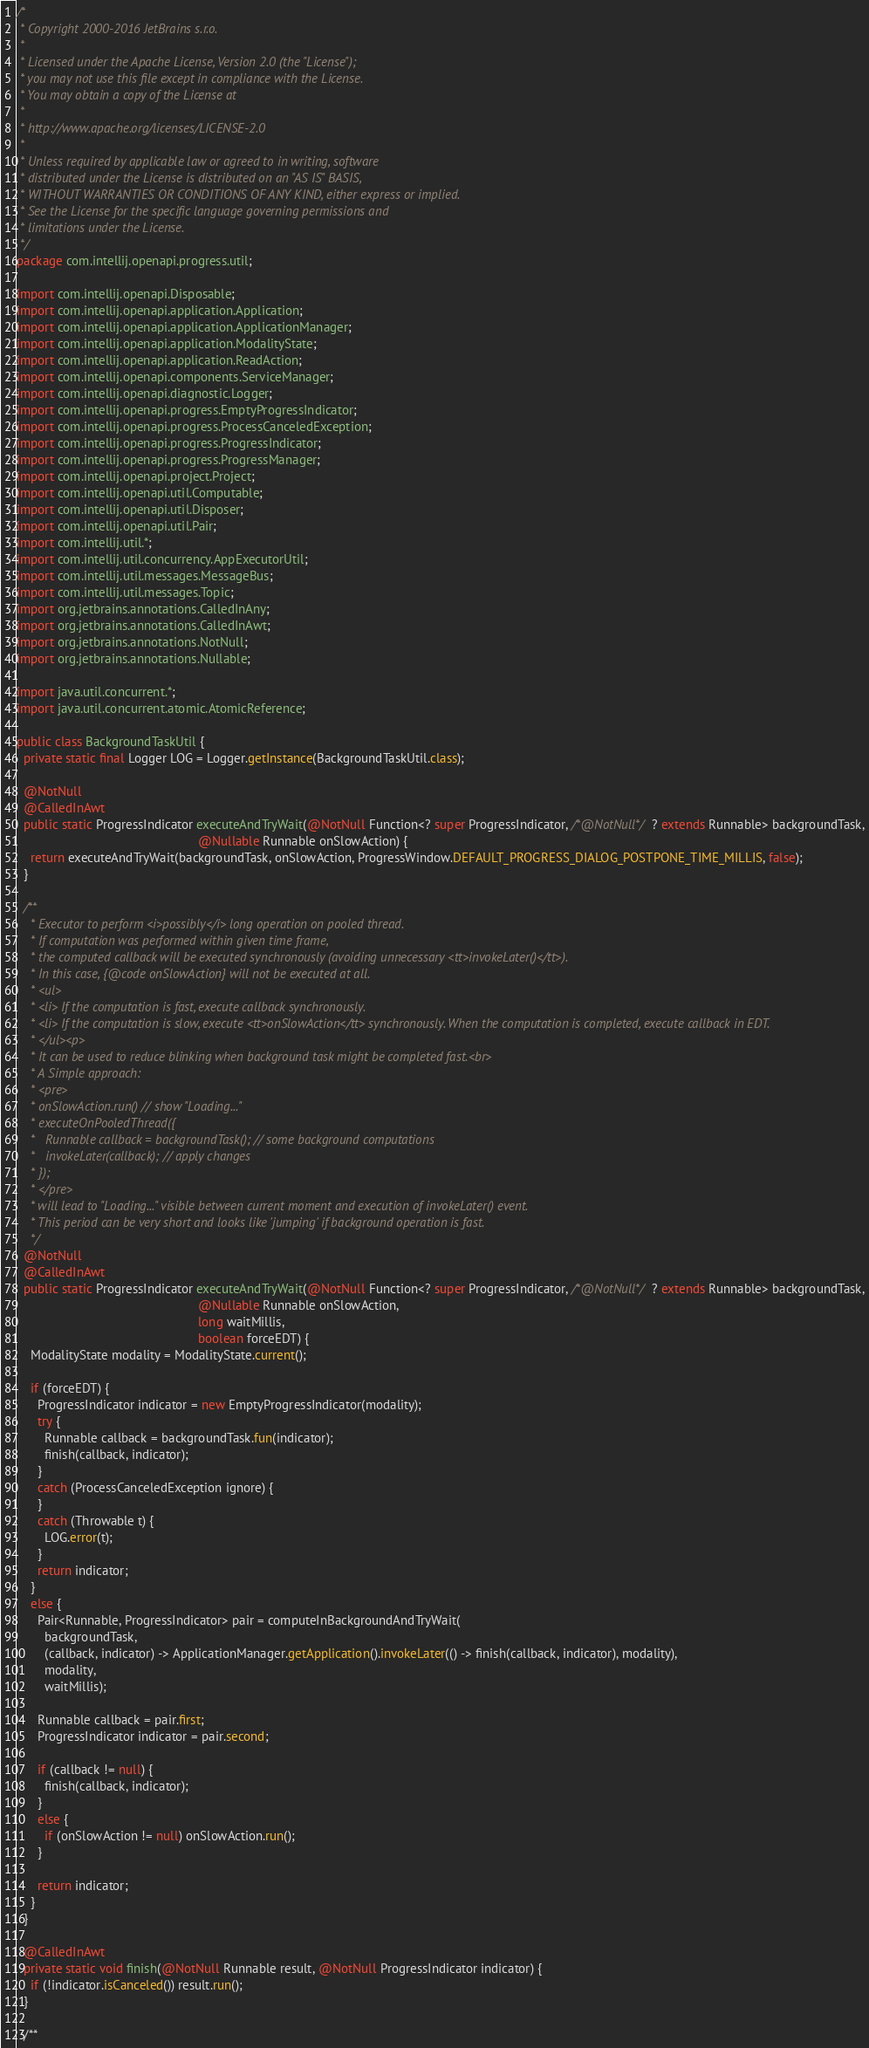Convert code to text. <code><loc_0><loc_0><loc_500><loc_500><_Java_>/*
 * Copyright 2000-2016 JetBrains s.r.o.
 *
 * Licensed under the Apache License, Version 2.0 (the "License");
 * you may not use this file except in compliance with the License.
 * You may obtain a copy of the License at
 *
 * http://www.apache.org/licenses/LICENSE-2.0
 *
 * Unless required by applicable law or agreed to in writing, software
 * distributed under the License is distributed on an "AS IS" BASIS,
 * WITHOUT WARRANTIES OR CONDITIONS OF ANY KIND, either express or implied.
 * See the License for the specific language governing permissions and
 * limitations under the License.
 */
package com.intellij.openapi.progress.util;

import com.intellij.openapi.Disposable;
import com.intellij.openapi.application.Application;
import com.intellij.openapi.application.ApplicationManager;
import com.intellij.openapi.application.ModalityState;
import com.intellij.openapi.application.ReadAction;
import com.intellij.openapi.components.ServiceManager;
import com.intellij.openapi.diagnostic.Logger;
import com.intellij.openapi.progress.EmptyProgressIndicator;
import com.intellij.openapi.progress.ProcessCanceledException;
import com.intellij.openapi.progress.ProgressIndicator;
import com.intellij.openapi.progress.ProgressManager;
import com.intellij.openapi.project.Project;
import com.intellij.openapi.util.Computable;
import com.intellij.openapi.util.Disposer;
import com.intellij.openapi.util.Pair;
import com.intellij.util.*;
import com.intellij.util.concurrency.AppExecutorUtil;
import com.intellij.util.messages.MessageBus;
import com.intellij.util.messages.Topic;
import org.jetbrains.annotations.CalledInAny;
import org.jetbrains.annotations.CalledInAwt;
import org.jetbrains.annotations.NotNull;
import org.jetbrains.annotations.Nullable;

import java.util.concurrent.*;
import java.util.concurrent.atomic.AtomicReference;

public class BackgroundTaskUtil {
  private static final Logger LOG = Logger.getInstance(BackgroundTaskUtil.class);

  @NotNull
  @CalledInAwt
  public static ProgressIndicator executeAndTryWait(@NotNull Function<? super ProgressIndicator, /*@NotNull*/ ? extends Runnable> backgroundTask,
                                                    @Nullable Runnable onSlowAction) {
    return executeAndTryWait(backgroundTask, onSlowAction, ProgressWindow.DEFAULT_PROGRESS_DIALOG_POSTPONE_TIME_MILLIS, false);
  }

  /**
    * Executor to perform <i>possibly</i> long operation on pooled thread.
    * If computation was performed within given time frame,
    * the computed callback will be executed synchronously (avoiding unnecessary <tt>invokeLater()</tt>).
    * In this case, {@code onSlowAction} will not be executed at all.
    * <ul>
    * <li> If the computation is fast, execute callback synchronously.
    * <li> If the computation is slow, execute <tt>onSlowAction</tt> synchronously. When the computation is completed, execute callback in EDT.
    * </ul><p>
    * It can be used to reduce blinking when background task might be completed fast.<br>
    * A Simple approach:
    * <pre>
    * onSlowAction.run() // show "Loading..."
    * executeOnPooledThread({
    *   Runnable callback = backgroundTask(); // some background computations
    *   invokeLater(callback); // apply changes
    * });
    * </pre>
    * will lead to "Loading..." visible between current moment and execution of invokeLater() event.
    * This period can be very short and looks like 'jumping' if background operation is fast.
    */
  @NotNull
  @CalledInAwt
  public static ProgressIndicator executeAndTryWait(@NotNull Function<? super ProgressIndicator, /*@NotNull*/ ? extends Runnable> backgroundTask,
                                                    @Nullable Runnable onSlowAction,
                                                    long waitMillis,
                                                    boolean forceEDT) {
    ModalityState modality = ModalityState.current();

    if (forceEDT) {
      ProgressIndicator indicator = new EmptyProgressIndicator(modality);
      try {
        Runnable callback = backgroundTask.fun(indicator);
        finish(callback, indicator);
      }
      catch (ProcessCanceledException ignore) {
      }
      catch (Throwable t) {
        LOG.error(t);
      }
      return indicator;
    }
    else {
      Pair<Runnable, ProgressIndicator> pair = computeInBackgroundAndTryWait(
        backgroundTask,
        (callback, indicator) -> ApplicationManager.getApplication().invokeLater(() -> finish(callback, indicator), modality),
        modality,
        waitMillis);

      Runnable callback = pair.first;
      ProgressIndicator indicator = pair.second;

      if (callback != null) {
        finish(callback, indicator);
      }
      else {
        if (onSlowAction != null) onSlowAction.run();
      }

      return indicator;
    }
  }

  @CalledInAwt
  private static void finish(@NotNull Runnable result, @NotNull ProgressIndicator indicator) {
    if (!indicator.isCanceled()) result.run();
  }

  /**</code> 